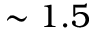Convert formula to latex. <formula><loc_0><loc_0><loc_500><loc_500>\sim 1 . 5</formula> 